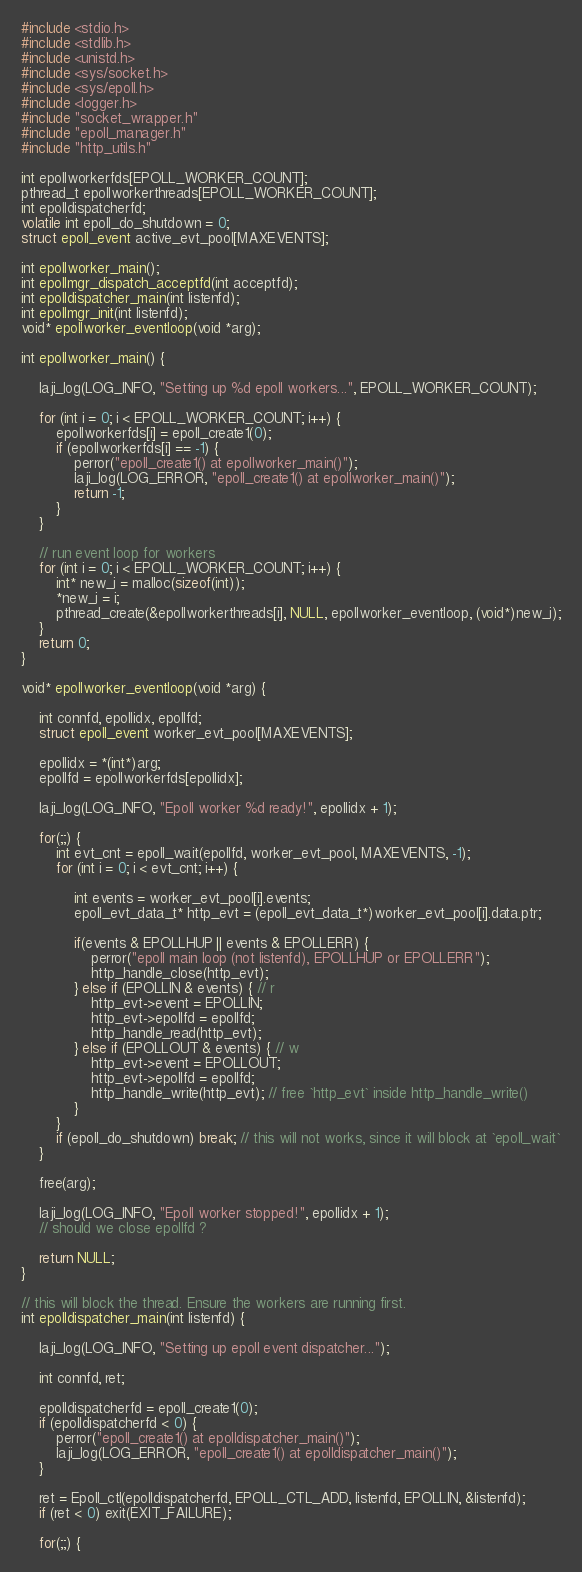Convert code to text. <code><loc_0><loc_0><loc_500><loc_500><_C_>#include <stdio.h>
#include <stdlib.h>
#include <unistd.h>
#include <sys/socket.h>
#include <sys/epoll.h>
#include <logger.h>
#include "socket_wrapper.h"
#include "epoll_manager.h"
#include "http_utils.h"

int epollworkerfds[EPOLL_WORKER_COUNT];
pthread_t epollworkerthreads[EPOLL_WORKER_COUNT];
int epolldispatcherfd;
volatile int epoll_do_shutdown = 0;
struct epoll_event active_evt_pool[MAXEVENTS];

int epollworker_main();
int epollmgr_dispatch_acceptfd(int acceptfd);
int epolldispatcher_main(int listenfd);
int epollmgr_init(int listenfd);
void* epollworker_eventloop(void *arg);

int epollworker_main() {

    laji_log(LOG_INFO, "Setting up %d epoll workers...", EPOLL_WORKER_COUNT);
    
    for (int i = 0; i < EPOLL_WORKER_COUNT; i++) {
        epollworkerfds[i] = epoll_create1(0);
        if (epollworkerfds[i] == -1) {
            perror("epoll_create1() at epollworker_main()");
            laji_log(LOG_ERROR, "epoll_create1() at epollworker_main()");
            return -1;
        }
    }

    // run event loop for workers
    for (int i = 0; i < EPOLL_WORKER_COUNT; i++) {
        int* new_i = malloc(sizeof(int));
        *new_i = i;
        pthread_create(&epollworkerthreads[i], NULL, epollworker_eventloop, (void*)new_i);
    }
    return 0;
}

void* epollworker_eventloop(void *arg) {

    int connfd, epollidx, epollfd;
    struct epoll_event worker_evt_pool[MAXEVENTS];

    epollidx = *(int*)arg;
    epollfd = epollworkerfds[epollidx];

    laji_log(LOG_INFO, "Epoll worker %d ready!", epollidx + 1);

    for(;;) {
        int evt_cnt = epoll_wait(epollfd, worker_evt_pool, MAXEVENTS, -1);
        for (int i = 0; i < evt_cnt; i++) {

            int events = worker_evt_pool[i].events;
            epoll_evt_data_t* http_evt = (epoll_evt_data_t*)worker_evt_pool[i].data.ptr;

            if(events & EPOLLHUP || events & EPOLLERR) { 
                perror("epoll main loop (not listenfd), EPOLLHUP or EPOLLERR");
                http_handle_close(http_evt);
            } else if (EPOLLIN & events) { // r
                http_evt->event = EPOLLIN;
                http_evt->epollfd = epollfd;
                http_handle_read(http_evt);
            } else if (EPOLLOUT & events) { // w
                http_evt->event = EPOLLOUT;
                http_evt->epollfd = epollfd;
                http_handle_write(http_evt); // free `http_evt` inside http_handle_write()
            }
        }
        if (epoll_do_shutdown) break; // this will not works, since it will block at `epoll_wait`
    }

    free(arg);

    laji_log(LOG_INFO, "Epoll worker stopped!", epollidx + 1);
    // should we close epollfd ?

    return NULL;
}

// this will block the thread. Ensure the workers are running first.
int epolldispatcher_main(int listenfd) {

    laji_log(LOG_INFO, "Setting up epoll event dispatcher...");

    int connfd, ret;

    epolldispatcherfd = epoll_create1(0);
    if (epolldispatcherfd < 0) {
        perror("epoll_create1() at epolldispatcher_main()");
        laji_log(LOG_ERROR, "epoll_create1() at epolldispatcher_main()");
    }

    ret = Epoll_ctl(epolldispatcherfd, EPOLL_CTL_ADD, listenfd, EPOLLIN, &listenfd);
    if (ret < 0) exit(EXIT_FAILURE);

    for(;;) {</code> 